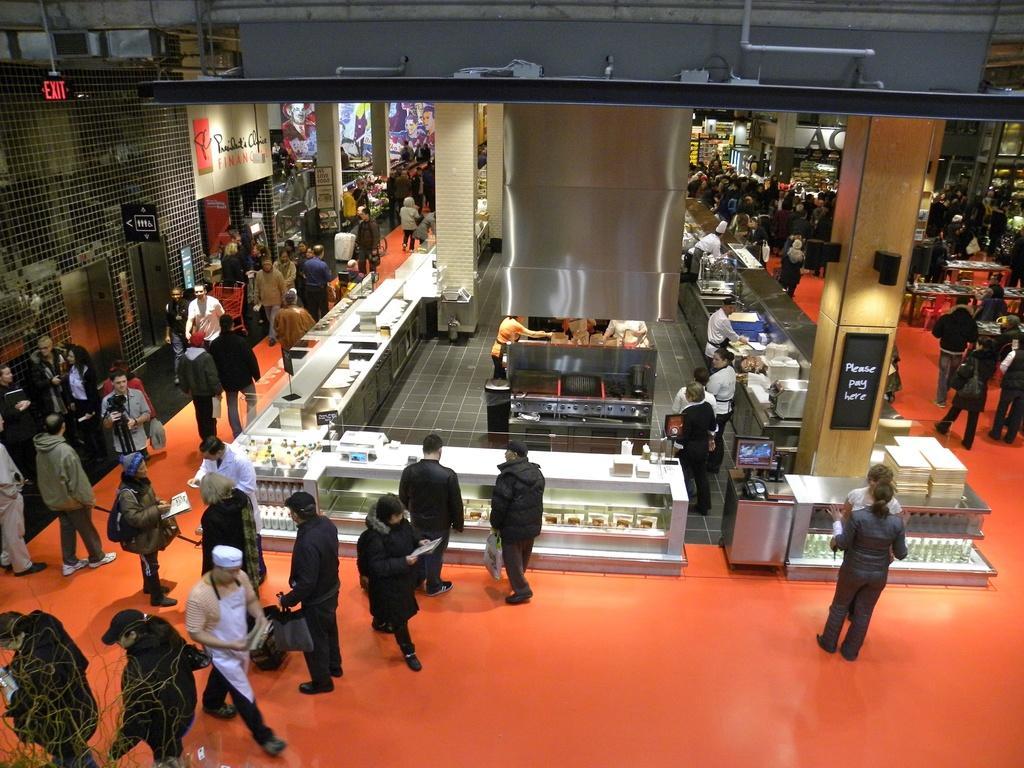In one or two sentences, can you explain what this image depicts? In this image, we can see people on the floor. In the middle of the image, we can see the desks. On top of that there are so many things and objects. On the right side of the image, we can see a pillar with a board. In the background, we can see pillars, people and few objects. On the left side of the image, we can see metal objects. 